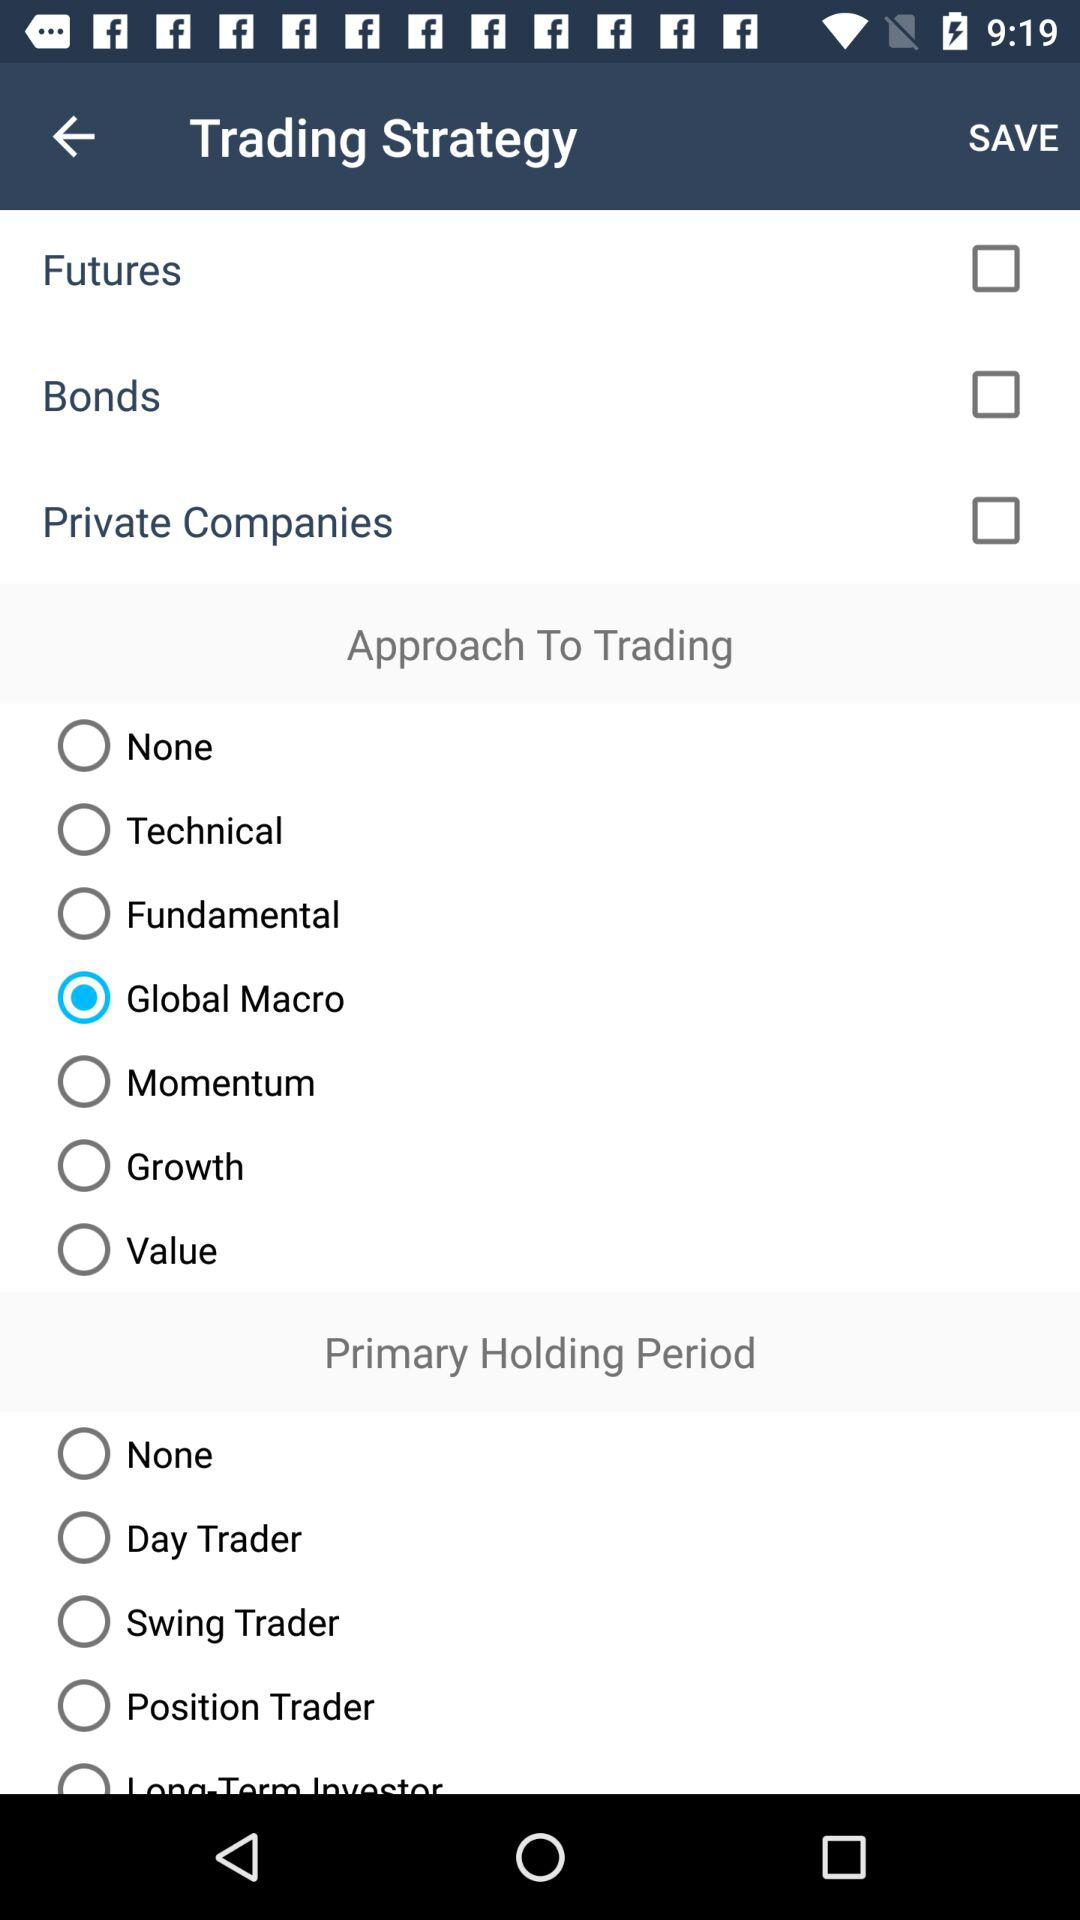Which option has been selected in "Approach To Trading"? The selected option in "Approach To Trading" is "Global Macro". 